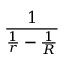Convert formula to latex. <formula><loc_0><loc_0><loc_500><loc_500>\frac { 1 } { { \frac { 1 } { r } } - { \frac { 1 } { R } } }</formula> 